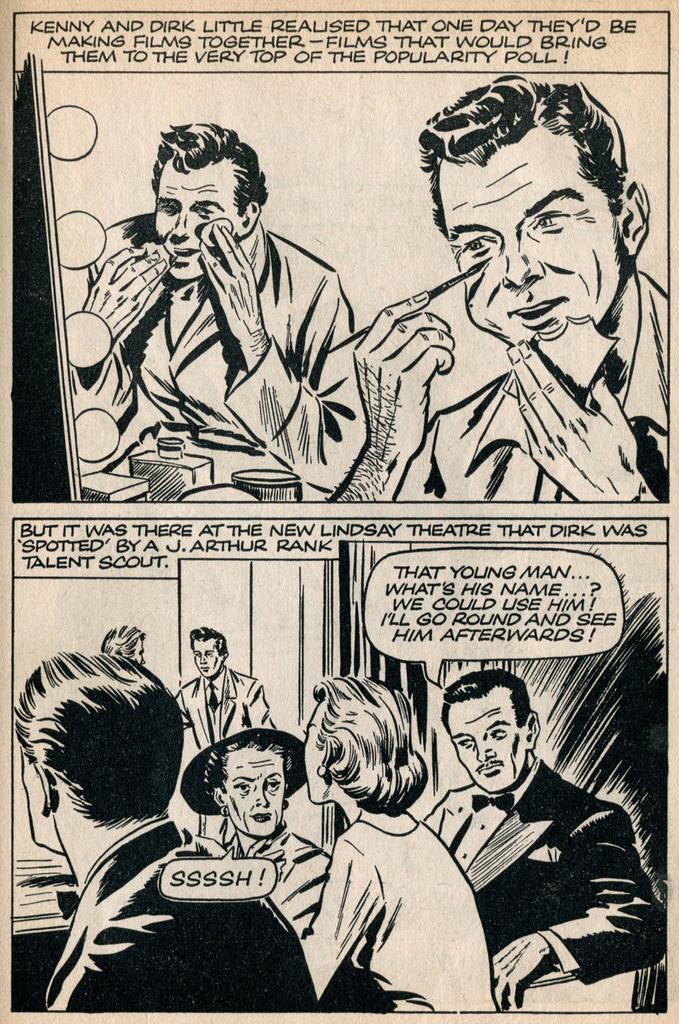What are the men's names?
Your answer should be very brief. Kenny and dirk. What is the woman telling the men to do?
Provide a short and direct response. Ssssh!. 